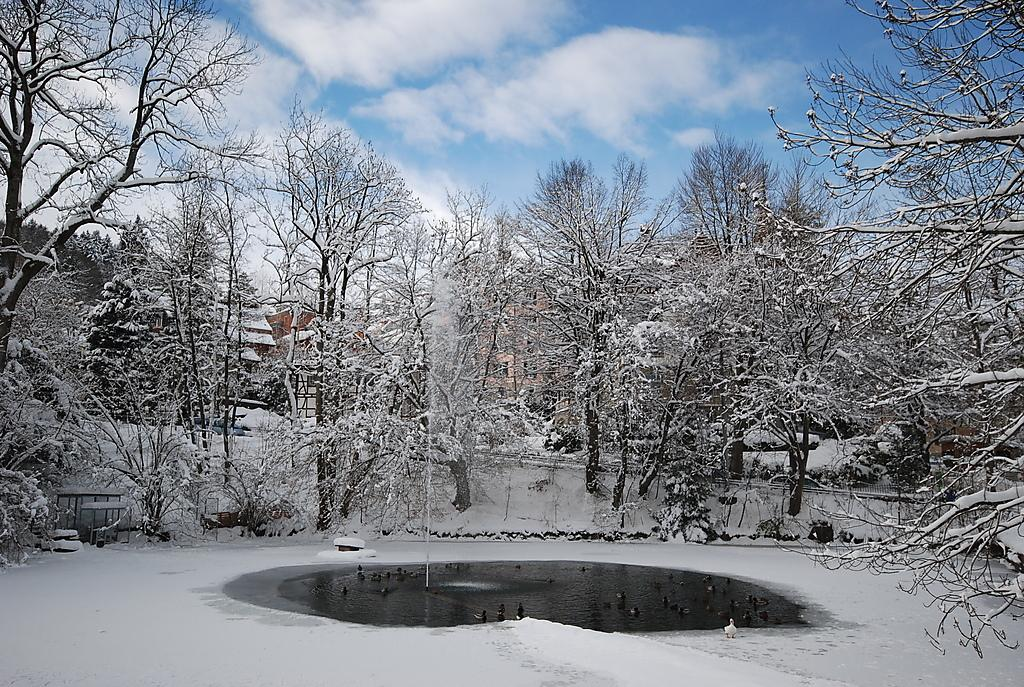What animals are present in the image? There is a group of ducks in the image. Where are the ducks located? The ducks are on water in the image. What type of vegetation can be seen in the image? There are trees in the image. What is the weather like in the image? There is snow in the image, indicating a cold or wintry environment. What structures are visible in the image? There are buildings in the image. What is visible in the background of the image? The sky is visible in the background of the image, and clouds are present in the sky. Can you see any dinosaurs in the image? No, there are no dinosaurs present in the image. What does the group of ducks feel about their decision to be in the image? The ducks' feelings or regrets cannot be determined from the image. 